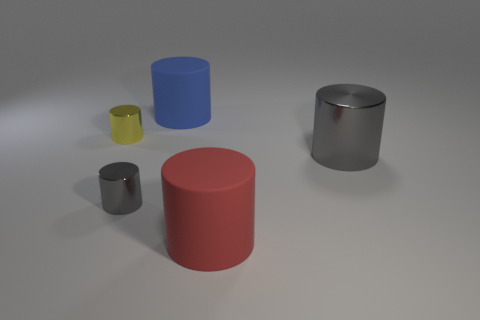Subtract all gray cylinders. How many cylinders are left? 3 Subtract all gray cylinders. How many cylinders are left? 3 Subtract 3 cylinders. How many cylinders are left? 2 Add 3 big green metallic things. How many objects exist? 8 Subtract all metal cylinders. Subtract all rubber cylinders. How many objects are left? 0 Add 2 red things. How many red things are left? 3 Add 1 blue matte cylinders. How many blue matte cylinders exist? 2 Subtract 0 yellow blocks. How many objects are left? 5 Subtract all gray cylinders. Subtract all gray blocks. How many cylinders are left? 3 Subtract all blue blocks. How many blue cylinders are left? 1 